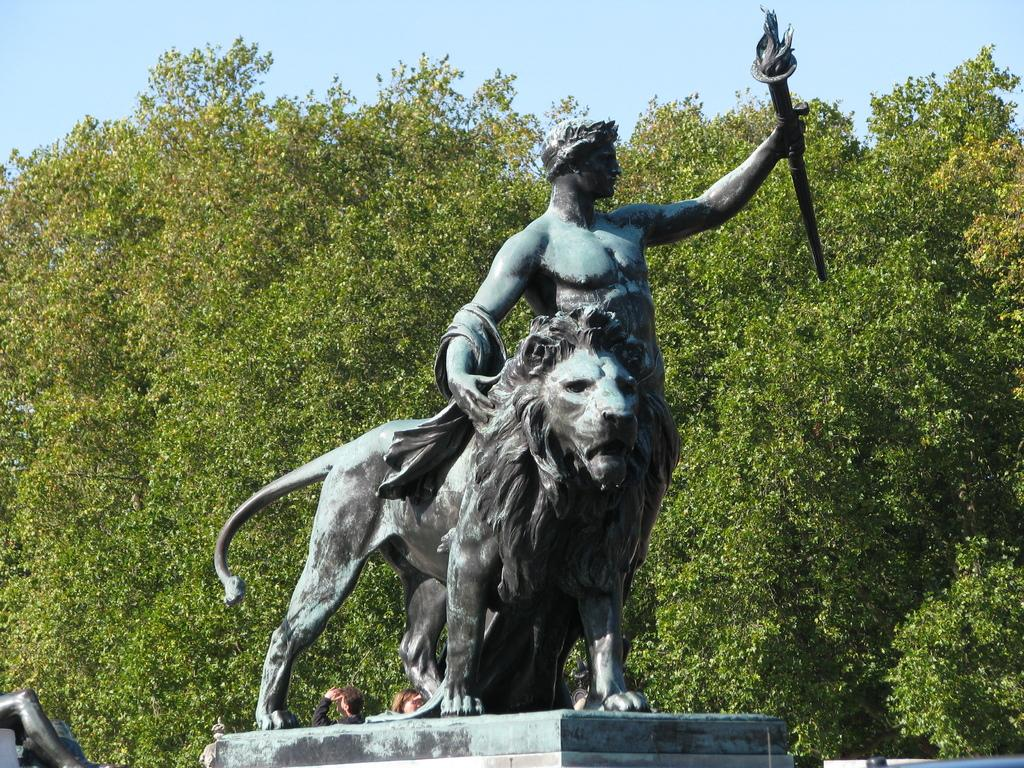What is the main subject in the center of the image? There is a sculpture in the center of the image. What can be seen in the background of the image? Trees are present in the background of the image. What is visible at the top of the image? The sky is visible at the top of the image. What type of ocean can be seen in the image? There is no ocean present in the image; it features a sculpture, trees, and the sky. 